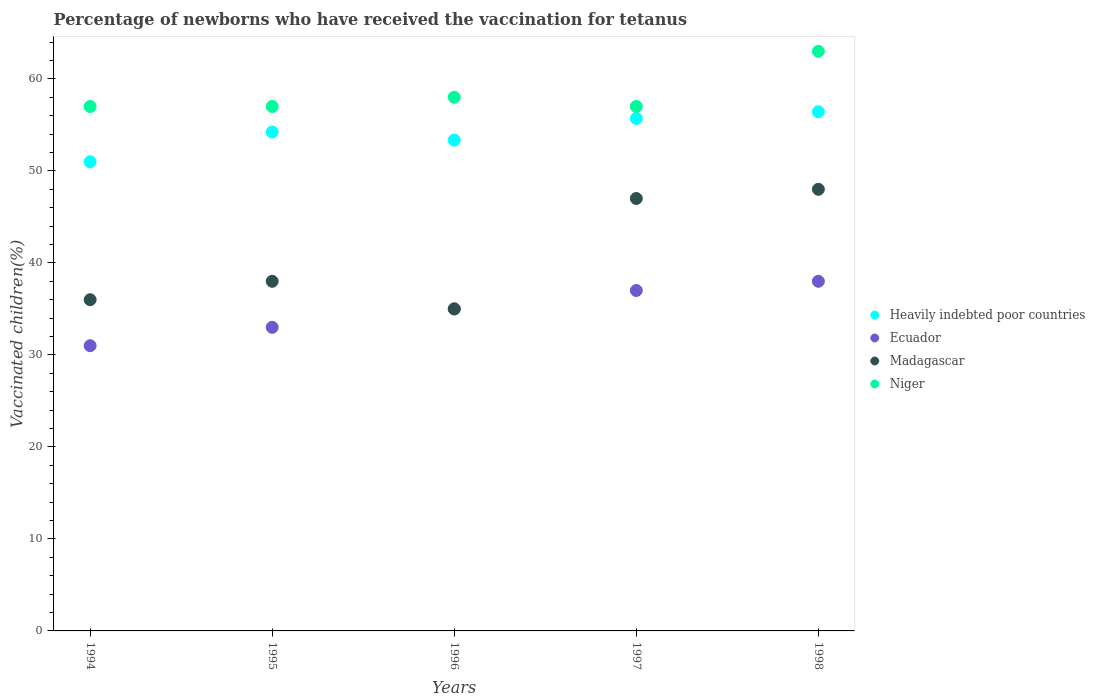How many different coloured dotlines are there?
Make the answer very short. 4. Is the number of dotlines equal to the number of legend labels?
Your answer should be very brief. Yes. What is the percentage of vaccinated children in Heavily indebted poor countries in 1994?
Keep it short and to the point. 50.99. Across all years, what is the maximum percentage of vaccinated children in Ecuador?
Give a very brief answer. 38. Across all years, what is the minimum percentage of vaccinated children in Heavily indebted poor countries?
Give a very brief answer. 50.99. In which year was the percentage of vaccinated children in Madagascar maximum?
Ensure brevity in your answer.  1998. In which year was the percentage of vaccinated children in Madagascar minimum?
Provide a short and direct response. 1996. What is the total percentage of vaccinated children in Heavily indebted poor countries in the graph?
Your answer should be very brief. 270.7. What is the difference between the percentage of vaccinated children in Niger in 1998 and the percentage of vaccinated children in Heavily indebted poor countries in 1995?
Your response must be concise. 8.77. What is the average percentage of vaccinated children in Madagascar per year?
Your response must be concise. 40.8. In the year 1996, what is the difference between the percentage of vaccinated children in Niger and percentage of vaccinated children in Madagascar?
Your response must be concise. 23. In how many years, is the percentage of vaccinated children in Niger greater than 60 %?
Offer a very short reply. 1. What is the ratio of the percentage of vaccinated children in Ecuador in 1997 to that in 1998?
Your response must be concise. 0.97. Is the percentage of vaccinated children in Madagascar in 1994 less than that in 1997?
Keep it short and to the point. Yes. Is the difference between the percentage of vaccinated children in Niger in 1996 and 1998 greater than the difference between the percentage of vaccinated children in Madagascar in 1996 and 1998?
Give a very brief answer. Yes. What is the difference between the highest and the lowest percentage of vaccinated children in Heavily indebted poor countries?
Provide a short and direct response. 5.44. Is the sum of the percentage of vaccinated children in Niger in 1994 and 1996 greater than the maximum percentage of vaccinated children in Madagascar across all years?
Your answer should be compact. Yes. Is it the case that in every year, the sum of the percentage of vaccinated children in Niger and percentage of vaccinated children in Ecuador  is greater than the sum of percentage of vaccinated children in Madagascar and percentage of vaccinated children in Heavily indebted poor countries?
Offer a very short reply. Yes. Is the percentage of vaccinated children in Madagascar strictly less than the percentage of vaccinated children in Heavily indebted poor countries over the years?
Your answer should be very brief. Yes. What is the difference between two consecutive major ticks on the Y-axis?
Your answer should be compact. 10. Does the graph contain any zero values?
Offer a very short reply. No. What is the title of the graph?
Give a very brief answer. Percentage of newborns who have received the vaccination for tetanus. Does "Ukraine" appear as one of the legend labels in the graph?
Your answer should be very brief. No. What is the label or title of the X-axis?
Your response must be concise. Years. What is the label or title of the Y-axis?
Keep it short and to the point. Vaccinated children(%). What is the Vaccinated children(%) in Heavily indebted poor countries in 1994?
Offer a terse response. 50.99. What is the Vaccinated children(%) in Heavily indebted poor countries in 1995?
Keep it short and to the point. 54.23. What is the Vaccinated children(%) in Madagascar in 1995?
Give a very brief answer. 38. What is the Vaccinated children(%) in Heavily indebted poor countries in 1996?
Your answer should be compact. 53.35. What is the Vaccinated children(%) in Ecuador in 1996?
Your answer should be very brief. 35. What is the Vaccinated children(%) in Niger in 1996?
Offer a terse response. 58. What is the Vaccinated children(%) in Heavily indebted poor countries in 1997?
Provide a short and direct response. 55.7. What is the Vaccinated children(%) of Ecuador in 1997?
Make the answer very short. 37. What is the Vaccinated children(%) of Madagascar in 1997?
Keep it short and to the point. 47. What is the Vaccinated children(%) of Niger in 1997?
Ensure brevity in your answer.  57. What is the Vaccinated children(%) of Heavily indebted poor countries in 1998?
Give a very brief answer. 56.43. What is the Vaccinated children(%) of Niger in 1998?
Your response must be concise. 63. Across all years, what is the maximum Vaccinated children(%) of Heavily indebted poor countries?
Your answer should be very brief. 56.43. Across all years, what is the maximum Vaccinated children(%) in Madagascar?
Offer a very short reply. 48. Across all years, what is the minimum Vaccinated children(%) of Heavily indebted poor countries?
Ensure brevity in your answer.  50.99. What is the total Vaccinated children(%) of Heavily indebted poor countries in the graph?
Offer a terse response. 270.7. What is the total Vaccinated children(%) of Ecuador in the graph?
Give a very brief answer. 174. What is the total Vaccinated children(%) of Madagascar in the graph?
Provide a short and direct response. 204. What is the total Vaccinated children(%) of Niger in the graph?
Your answer should be compact. 292. What is the difference between the Vaccinated children(%) of Heavily indebted poor countries in 1994 and that in 1995?
Provide a short and direct response. -3.23. What is the difference between the Vaccinated children(%) of Ecuador in 1994 and that in 1995?
Your response must be concise. -2. What is the difference between the Vaccinated children(%) of Madagascar in 1994 and that in 1995?
Offer a terse response. -2. What is the difference between the Vaccinated children(%) of Niger in 1994 and that in 1995?
Your answer should be very brief. 0. What is the difference between the Vaccinated children(%) in Heavily indebted poor countries in 1994 and that in 1996?
Make the answer very short. -2.36. What is the difference between the Vaccinated children(%) in Ecuador in 1994 and that in 1996?
Your response must be concise. -4. What is the difference between the Vaccinated children(%) in Heavily indebted poor countries in 1994 and that in 1997?
Give a very brief answer. -4.71. What is the difference between the Vaccinated children(%) of Madagascar in 1994 and that in 1997?
Your answer should be very brief. -11. What is the difference between the Vaccinated children(%) of Heavily indebted poor countries in 1994 and that in 1998?
Give a very brief answer. -5.44. What is the difference between the Vaccinated children(%) in Madagascar in 1994 and that in 1998?
Your response must be concise. -12. What is the difference between the Vaccinated children(%) in Niger in 1994 and that in 1998?
Give a very brief answer. -6. What is the difference between the Vaccinated children(%) in Heavily indebted poor countries in 1995 and that in 1996?
Offer a terse response. 0.88. What is the difference between the Vaccinated children(%) of Ecuador in 1995 and that in 1996?
Provide a succinct answer. -2. What is the difference between the Vaccinated children(%) in Heavily indebted poor countries in 1995 and that in 1997?
Your answer should be compact. -1.48. What is the difference between the Vaccinated children(%) in Niger in 1995 and that in 1997?
Provide a short and direct response. 0. What is the difference between the Vaccinated children(%) of Heavily indebted poor countries in 1995 and that in 1998?
Provide a succinct answer. -2.2. What is the difference between the Vaccinated children(%) in Ecuador in 1995 and that in 1998?
Your answer should be very brief. -5. What is the difference between the Vaccinated children(%) in Heavily indebted poor countries in 1996 and that in 1997?
Your answer should be compact. -2.36. What is the difference between the Vaccinated children(%) in Niger in 1996 and that in 1997?
Your response must be concise. 1. What is the difference between the Vaccinated children(%) of Heavily indebted poor countries in 1996 and that in 1998?
Your answer should be compact. -3.08. What is the difference between the Vaccinated children(%) in Ecuador in 1996 and that in 1998?
Make the answer very short. -3. What is the difference between the Vaccinated children(%) in Niger in 1996 and that in 1998?
Give a very brief answer. -5. What is the difference between the Vaccinated children(%) of Heavily indebted poor countries in 1997 and that in 1998?
Your answer should be very brief. -0.72. What is the difference between the Vaccinated children(%) in Heavily indebted poor countries in 1994 and the Vaccinated children(%) in Ecuador in 1995?
Ensure brevity in your answer.  17.99. What is the difference between the Vaccinated children(%) in Heavily indebted poor countries in 1994 and the Vaccinated children(%) in Madagascar in 1995?
Your answer should be compact. 12.99. What is the difference between the Vaccinated children(%) of Heavily indebted poor countries in 1994 and the Vaccinated children(%) of Niger in 1995?
Provide a short and direct response. -6.01. What is the difference between the Vaccinated children(%) in Ecuador in 1994 and the Vaccinated children(%) in Madagascar in 1995?
Ensure brevity in your answer.  -7. What is the difference between the Vaccinated children(%) in Ecuador in 1994 and the Vaccinated children(%) in Niger in 1995?
Ensure brevity in your answer.  -26. What is the difference between the Vaccinated children(%) of Heavily indebted poor countries in 1994 and the Vaccinated children(%) of Ecuador in 1996?
Your answer should be compact. 15.99. What is the difference between the Vaccinated children(%) in Heavily indebted poor countries in 1994 and the Vaccinated children(%) in Madagascar in 1996?
Your answer should be very brief. 15.99. What is the difference between the Vaccinated children(%) of Heavily indebted poor countries in 1994 and the Vaccinated children(%) of Niger in 1996?
Make the answer very short. -7.01. What is the difference between the Vaccinated children(%) in Heavily indebted poor countries in 1994 and the Vaccinated children(%) in Ecuador in 1997?
Ensure brevity in your answer.  13.99. What is the difference between the Vaccinated children(%) in Heavily indebted poor countries in 1994 and the Vaccinated children(%) in Madagascar in 1997?
Your response must be concise. 3.99. What is the difference between the Vaccinated children(%) of Heavily indebted poor countries in 1994 and the Vaccinated children(%) of Niger in 1997?
Offer a terse response. -6.01. What is the difference between the Vaccinated children(%) of Ecuador in 1994 and the Vaccinated children(%) of Madagascar in 1997?
Ensure brevity in your answer.  -16. What is the difference between the Vaccinated children(%) of Ecuador in 1994 and the Vaccinated children(%) of Niger in 1997?
Offer a very short reply. -26. What is the difference between the Vaccinated children(%) in Madagascar in 1994 and the Vaccinated children(%) in Niger in 1997?
Provide a short and direct response. -21. What is the difference between the Vaccinated children(%) in Heavily indebted poor countries in 1994 and the Vaccinated children(%) in Ecuador in 1998?
Keep it short and to the point. 12.99. What is the difference between the Vaccinated children(%) in Heavily indebted poor countries in 1994 and the Vaccinated children(%) in Madagascar in 1998?
Provide a succinct answer. 2.99. What is the difference between the Vaccinated children(%) of Heavily indebted poor countries in 1994 and the Vaccinated children(%) of Niger in 1998?
Ensure brevity in your answer.  -12.01. What is the difference between the Vaccinated children(%) in Ecuador in 1994 and the Vaccinated children(%) in Madagascar in 1998?
Your answer should be very brief. -17. What is the difference between the Vaccinated children(%) of Ecuador in 1994 and the Vaccinated children(%) of Niger in 1998?
Provide a short and direct response. -32. What is the difference between the Vaccinated children(%) of Heavily indebted poor countries in 1995 and the Vaccinated children(%) of Ecuador in 1996?
Give a very brief answer. 19.23. What is the difference between the Vaccinated children(%) of Heavily indebted poor countries in 1995 and the Vaccinated children(%) of Madagascar in 1996?
Provide a short and direct response. 19.23. What is the difference between the Vaccinated children(%) in Heavily indebted poor countries in 1995 and the Vaccinated children(%) in Niger in 1996?
Your answer should be very brief. -3.77. What is the difference between the Vaccinated children(%) in Ecuador in 1995 and the Vaccinated children(%) in Madagascar in 1996?
Provide a succinct answer. -2. What is the difference between the Vaccinated children(%) of Ecuador in 1995 and the Vaccinated children(%) of Niger in 1996?
Give a very brief answer. -25. What is the difference between the Vaccinated children(%) of Madagascar in 1995 and the Vaccinated children(%) of Niger in 1996?
Your answer should be very brief. -20. What is the difference between the Vaccinated children(%) in Heavily indebted poor countries in 1995 and the Vaccinated children(%) in Ecuador in 1997?
Your response must be concise. 17.23. What is the difference between the Vaccinated children(%) of Heavily indebted poor countries in 1995 and the Vaccinated children(%) of Madagascar in 1997?
Offer a very short reply. 7.23. What is the difference between the Vaccinated children(%) in Heavily indebted poor countries in 1995 and the Vaccinated children(%) in Niger in 1997?
Offer a very short reply. -2.77. What is the difference between the Vaccinated children(%) in Heavily indebted poor countries in 1995 and the Vaccinated children(%) in Ecuador in 1998?
Keep it short and to the point. 16.23. What is the difference between the Vaccinated children(%) of Heavily indebted poor countries in 1995 and the Vaccinated children(%) of Madagascar in 1998?
Keep it short and to the point. 6.23. What is the difference between the Vaccinated children(%) in Heavily indebted poor countries in 1995 and the Vaccinated children(%) in Niger in 1998?
Give a very brief answer. -8.77. What is the difference between the Vaccinated children(%) of Ecuador in 1995 and the Vaccinated children(%) of Madagascar in 1998?
Give a very brief answer. -15. What is the difference between the Vaccinated children(%) in Ecuador in 1995 and the Vaccinated children(%) in Niger in 1998?
Offer a very short reply. -30. What is the difference between the Vaccinated children(%) in Heavily indebted poor countries in 1996 and the Vaccinated children(%) in Ecuador in 1997?
Provide a short and direct response. 16.35. What is the difference between the Vaccinated children(%) of Heavily indebted poor countries in 1996 and the Vaccinated children(%) of Madagascar in 1997?
Provide a succinct answer. 6.35. What is the difference between the Vaccinated children(%) of Heavily indebted poor countries in 1996 and the Vaccinated children(%) of Niger in 1997?
Ensure brevity in your answer.  -3.65. What is the difference between the Vaccinated children(%) in Ecuador in 1996 and the Vaccinated children(%) in Madagascar in 1997?
Your response must be concise. -12. What is the difference between the Vaccinated children(%) in Ecuador in 1996 and the Vaccinated children(%) in Niger in 1997?
Your response must be concise. -22. What is the difference between the Vaccinated children(%) in Madagascar in 1996 and the Vaccinated children(%) in Niger in 1997?
Give a very brief answer. -22. What is the difference between the Vaccinated children(%) of Heavily indebted poor countries in 1996 and the Vaccinated children(%) of Ecuador in 1998?
Keep it short and to the point. 15.35. What is the difference between the Vaccinated children(%) of Heavily indebted poor countries in 1996 and the Vaccinated children(%) of Madagascar in 1998?
Give a very brief answer. 5.35. What is the difference between the Vaccinated children(%) in Heavily indebted poor countries in 1996 and the Vaccinated children(%) in Niger in 1998?
Offer a terse response. -9.65. What is the difference between the Vaccinated children(%) in Madagascar in 1996 and the Vaccinated children(%) in Niger in 1998?
Your response must be concise. -28. What is the difference between the Vaccinated children(%) of Heavily indebted poor countries in 1997 and the Vaccinated children(%) of Ecuador in 1998?
Offer a terse response. 17.7. What is the difference between the Vaccinated children(%) of Heavily indebted poor countries in 1997 and the Vaccinated children(%) of Madagascar in 1998?
Ensure brevity in your answer.  7.7. What is the difference between the Vaccinated children(%) of Heavily indebted poor countries in 1997 and the Vaccinated children(%) of Niger in 1998?
Ensure brevity in your answer.  -7.3. What is the difference between the Vaccinated children(%) in Madagascar in 1997 and the Vaccinated children(%) in Niger in 1998?
Your answer should be very brief. -16. What is the average Vaccinated children(%) of Heavily indebted poor countries per year?
Give a very brief answer. 54.14. What is the average Vaccinated children(%) in Ecuador per year?
Provide a short and direct response. 34.8. What is the average Vaccinated children(%) of Madagascar per year?
Offer a very short reply. 40.8. What is the average Vaccinated children(%) of Niger per year?
Offer a terse response. 58.4. In the year 1994, what is the difference between the Vaccinated children(%) of Heavily indebted poor countries and Vaccinated children(%) of Ecuador?
Your response must be concise. 19.99. In the year 1994, what is the difference between the Vaccinated children(%) in Heavily indebted poor countries and Vaccinated children(%) in Madagascar?
Give a very brief answer. 14.99. In the year 1994, what is the difference between the Vaccinated children(%) in Heavily indebted poor countries and Vaccinated children(%) in Niger?
Keep it short and to the point. -6.01. In the year 1995, what is the difference between the Vaccinated children(%) of Heavily indebted poor countries and Vaccinated children(%) of Ecuador?
Give a very brief answer. 21.23. In the year 1995, what is the difference between the Vaccinated children(%) in Heavily indebted poor countries and Vaccinated children(%) in Madagascar?
Your answer should be very brief. 16.23. In the year 1995, what is the difference between the Vaccinated children(%) in Heavily indebted poor countries and Vaccinated children(%) in Niger?
Offer a very short reply. -2.77. In the year 1995, what is the difference between the Vaccinated children(%) of Madagascar and Vaccinated children(%) of Niger?
Offer a very short reply. -19. In the year 1996, what is the difference between the Vaccinated children(%) in Heavily indebted poor countries and Vaccinated children(%) in Ecuador?
Your answer should be very brief. 18.35. In the year 1996, what is the difference between the Vaccinated children(%) in Heavily indebted poor countries and Vaccinated children(%) in Madagascar?
Offer a very short reply. 18.35. In the year 1996, what is the difference between the Vaccinated children(%) of Heavily indebted poor countries and Vaccinated children(%) of Niger?
Your answer should be very brief. -4.65. In the year 1996, what is the difference between the Vaccinated children(%) of Ecuador and Vaccinated children(%) of Madagascar?
Ensure brevity in your answer.  0. In the year 1996, what is the difference between the Vaccinated children(%) of Ecuador and Vaccinated children(%) of Niger?
Offer a very short reply. -23. In the year 1996, what is the difference between the Vaccinated children(%) in Madagascar and Vaccinated children(%) in Niger?
Make the answer very short. -23. In the year 1997, what is the difference between the Vaccinated children(%) in Heavily indebted poor countries and Vaccinated children(%) in Ecuador?
Your answer should be compact. 18.7. In the year 1997, what is the difference between the Vaccinated children(%) in Heavily indebted poor countries and Vaccinated children(%) in Madagascar?
Provide a short and direct response. 8.7. In the year 1997, what is the difference between the Vaccinated children(%) of Heavily indebted poor countries and Vaccinated children(%) of Niger?
Provide a short and direct response. -1.3. In the year 1997, what is the difference between the Vaccinated children(%) in Ecuador and Vaccinated children(%) in Madagascar?
Provide a succinct answer. -10. In the year 1998, what is the difference between the Vaccinated children(%) of Heavily indebted poor countries and Vaccinated children(%) of Ecuador?
Provide a succinct answer. 18.43. In the year 1998, what is the difference between the Vaccinated children(%) of Heavily indebted poor countries and Vaccinated children(%) of Madagascar?
Provide a succinct answer. 8.43. In the year 1998, what is the difference between the Vaccinated children(%) in Heavily indebted poor countries and Vaccinated children(%) in Niger?
Your answer should be very brief. -6.57. In the year 1998, what is the difference between the Vaccinated children(%) in Ecuador and Vaccinated children(%) in Madagascar?
Ensure brevity in your answer.  -10. In the year 1998, what is the difference between the Vaccinated children(%) in Ecuador and Vaccinated children(%) in Niger?
Give a very brief answer. -25. In the year 1998, what is the difference between the Vaccinated children(%) in Madagascar and Vaccinated children(%) in Niger?
Your response must be concise. -15. What is the ratio of the Vaccinated children(%) in Heavily indebted poor countries in 1994 to that in 1995?
Keep it short and to the point. 0.94. What is the ratio of the Vaccinated children(%) of Ecuador in 1994 to that in 1995?
Your answer should be compact. 0.94. What is the ratio of the Vaccinated children(%) of Heavily indebted poor countries in 1994 to that in 1996?
Your answer should be very brief. 0.96. What is the ratio of the Vaccinated children(%) in Ecuador in 1994 to that in 1996?
Keep it short and to the point. 0.89. What is the ratio of the Vaccinated children(%) in Madagascar in 1994 to that in 1996?
Offer a terse response. 1.03. What is the ratio of the Vaccinated children(%) of Niger in 1994 to that in 1996?
Keep it short and to the point. 0.98. What is the ratio of the Vaccinated children(%) of Heavily indebted poor countries in 1994 to that in 1997?
Your answer should be very brief. 0.92. What is the ratio of the Vaccinated children(%) of Ecuador in 1994 to that in 1997?
Offer a very short reply. 0.84. What is the ratio of the Vaccinated children(%) in Madagascar in 1994 to that in 1997?
Make the answer very short. 0.77. What is the ratio of the Vaccinated children(%) in Niger in 1994 to that in 1997?
Make the answer very short. 1. What is the ratio of the Vaccinated children(%) of Heavily indebted poor countries in 1994 to that in 1998?
Keep it short and to the point. 0.9. What is the ratio of the Vaccinated children(%) of Ecuador in 1994 to that in 1998?
Keep it short and to the point. 0.82. What is the ratio of the Vaccinated children(%) in Niger in 1994 to that in 1998?
Provide a short and direct response. 0.9. What is the ratio of the Vaccinated children(%) in Heavily indebted poor countries in 1995 to that in 1996?
Give a very brief answer. 1.02. What is the ratio of the Vaccinated children(%) of Ecuador in 1995 to that in 1996?
Keep it short and to the point. 0.94. What is the ratio of the Vaccinated children(%) in Madagascar in 1995 to that in 1996?
Ensure brevity in your answer.  1.09. What is the ratio of the Vaccinated children(%) of Niger in 1995 to that in 1996?
Your response must be concise. 0.98. What is the ratio of the Vaccinated children(%) in Heavily indebted poor countries in 1995 to that in 1997?
Keep it short and to the point. 0.97. What is the ratio of the Vaccinated children(%) in Ecuador in 1995 to that in 1997?
Your answer should be compact. 0.89. What is the ratio of the Vaccinated children(%) in Madagascar in 1995 to that in 1997?
Keep it short and to the point. 0.81. What is the ratio of the Vaccinated children(%) in Niger in 1995 to that in 1997?
Offer a terse response. 1. What is the ratio of the Vaccinated children(%) in Ecuador in 1995 to that in 1998?
Give a very brief answer. 0.87. What is the ratio of the Vaccinated children(%) in Madagascar in 1995 to that in 1998?
Make the answer very short. 0.79. What is the ratio of the Vaccinated children(%) in Niger in 1995 to that in 1998?
Provide a short and direct response. 0.9. What is the ratio of the Vaccinated children(%) in Heavily indebted poor countries in 1996 to that in 1997?
Keep it short and to the point. 0.96. What is the ratio of the Vaccinated children(%) of Ecuador in 1996 to that in 1997?
Provide a short and direct response. 0.95. What is the ratio of the Vaccinated children(%) in Madagascar in 1996 to that in 1997?
Offer a very short reply. 0.74. What is the ratio of the Vaccinated children(%) in Niger in 1996 to that in 1997?
Offer a very short reply. 1.02. What is the ratio of the Vaccinated children(%) of Heavily indebted poor countries in 1996 to that in 1998?
Provide a succinct answer. 0.95. What is the ratio of the Vaccinated children(%) of Ecuador in 1996 to that in 1998?
Your answer should be compact. 0.92. What is the ratio of the Vaccinated children(%) of Madagascar in 1996 to that in 1998?
Offer a terse response. 0.73. What is the ratio of the Vaccinated children(%) of Niger in 1996 to that in 1998?
Provide a short and direct response. 0.92. What is the ratio of the Vaccinated children(%) in Heavily indebted poor countries in 1997 to that in 1998?
Offer a terse response. 0.99. What is the ratio of the Vaccinated children(%) of Ecuador in 1997 to that in 1998?
Ensure brevity in your answer.  0.97. What is the ratio of the Vaccinated children(%) of Madagascar in 1997 to that in 1998?
Your response must be concise. 0.98. What is the ratio of the Vaccinated children(%) in Niger in 1997 to that in 1998?
Provide a short and direct response. 0.9. What is the difference between the highest and the second highest Vaccinated children(%) in Heavily indebted poor countries?
Make the answer very short. 0.72. What is the difference between the highest and the second highest Vaccinated children(%) of Madagascar?
Give a very brief answer. 1. What is the difference between the highest and the second highest Vaccinated children(%) in Niger?
Keep it short and to the point. 5. What is the difference between the highest and the lowest Vaccinated children(%) of Heavily indebted poor countries?
Keep it short and to the point. 5.44. What is the difference between the highest and the lowest Vaccinated children(%) in Ecuador?
Offer a terse response. 7. 